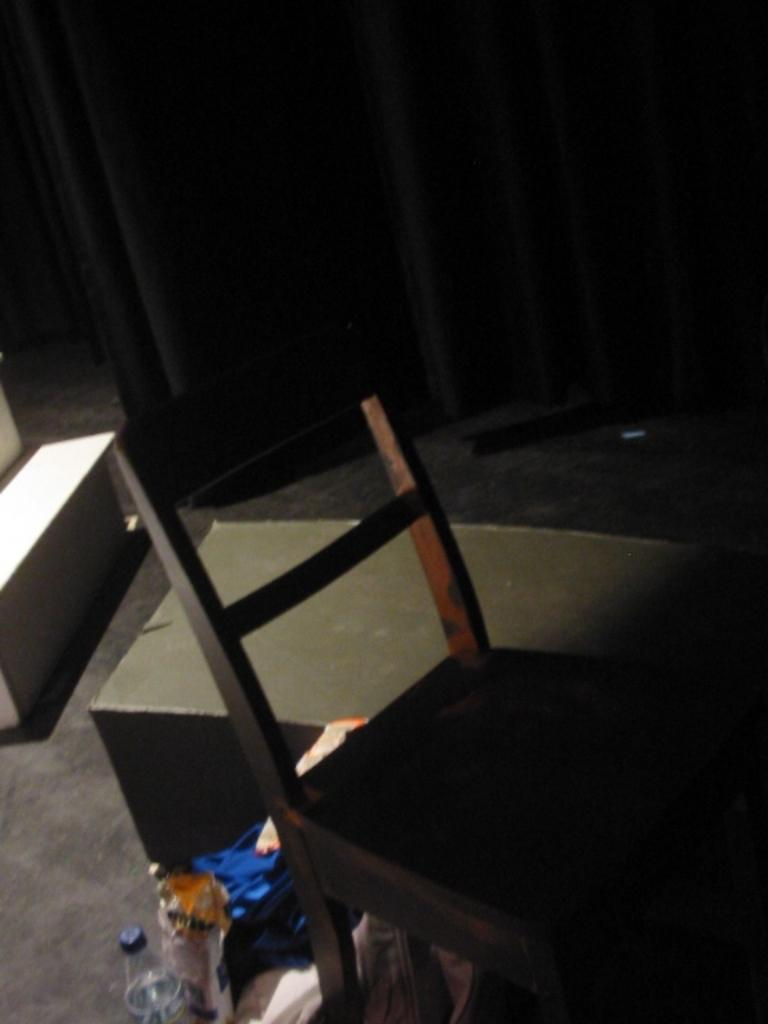What type of chair is in the image? There is a wooden chair in the image. What other piece of furniture is in the image? There is a table in the image. What can be seen on the floor in the image? There are objects on the floor in the image. What is in the background of the image? There is a curtain in the background of the image. What type of seed is growing through the hole in the wooden chair? There is no seed or hole present in the wooden chair in the image. 